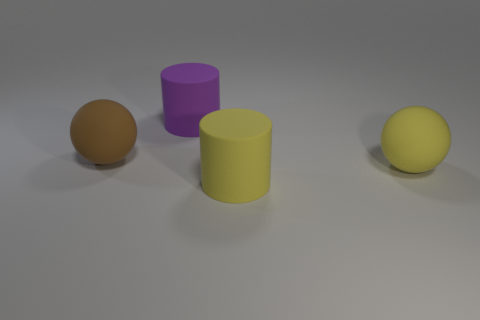Is the size of the yellow rubber sphere the same as the cylinder that is to the right of the large purple cylinder?
Ensure brevity in your answer.  Yes. What number of metal objects are either big things or big yellow objects?
Ensure brevity in your answer.  0. The big sphere in front of the big brown thing is what color?
Your answer should be compact. Yellow. There is a brown matte object that is the same size as the purple rubber thing; what is its shape?
Offer a terse response. Sphere. How many objects are either large cylinders behind the yellow matte ball or large cylinders in front of the big purple cylinder?
Provide a short and direct response. 2. There is another cylinder that is the same size as the purple matte cylinder; what material is it?
Provide a short and direct response. Rubber. There is a big object that is on the left side of the purple object; does it have the same shape as the big thing that is to the right of the large yellow cylinder?
Your response must be concise. Yes. What is the color of the matte cylinder that is to the right of the matte cylinder behind the large ball on the left side of the purple thing?
Offer a terse response. Yellow. Are there fewer matte things than large yellow cylinders?
Keep it short and to the point. No. There is a large thing that is behind the yellow matte ball and in front of the purple thing; what color is it?
Your answer should be very brief. Brown. 